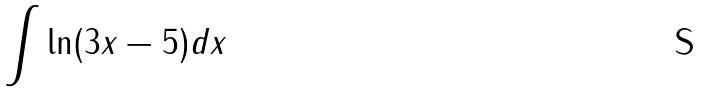<formula> <loc_0><loc_0><loc_500><loc_500>\int \ln ( 3 x - 5 ) d x</formula> 